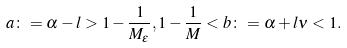<formula> <loc_0><loc_0><loc_500><loc_500>a \colon = \alpha - l > 1 - \frac { 1 } { M _ { \varepsilon } } , 1 - \frac { 1 } { M } < b \colon = \alpha + l \nu < 1 .</formula> 